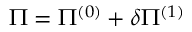Convert formula to latex. <formula><loc_0><loc_0><loc_500><loc_500>\Pi = \Pi ^ { ( 0 ) } + \delta \Pi ^ { ( 1 ) }</formula> 